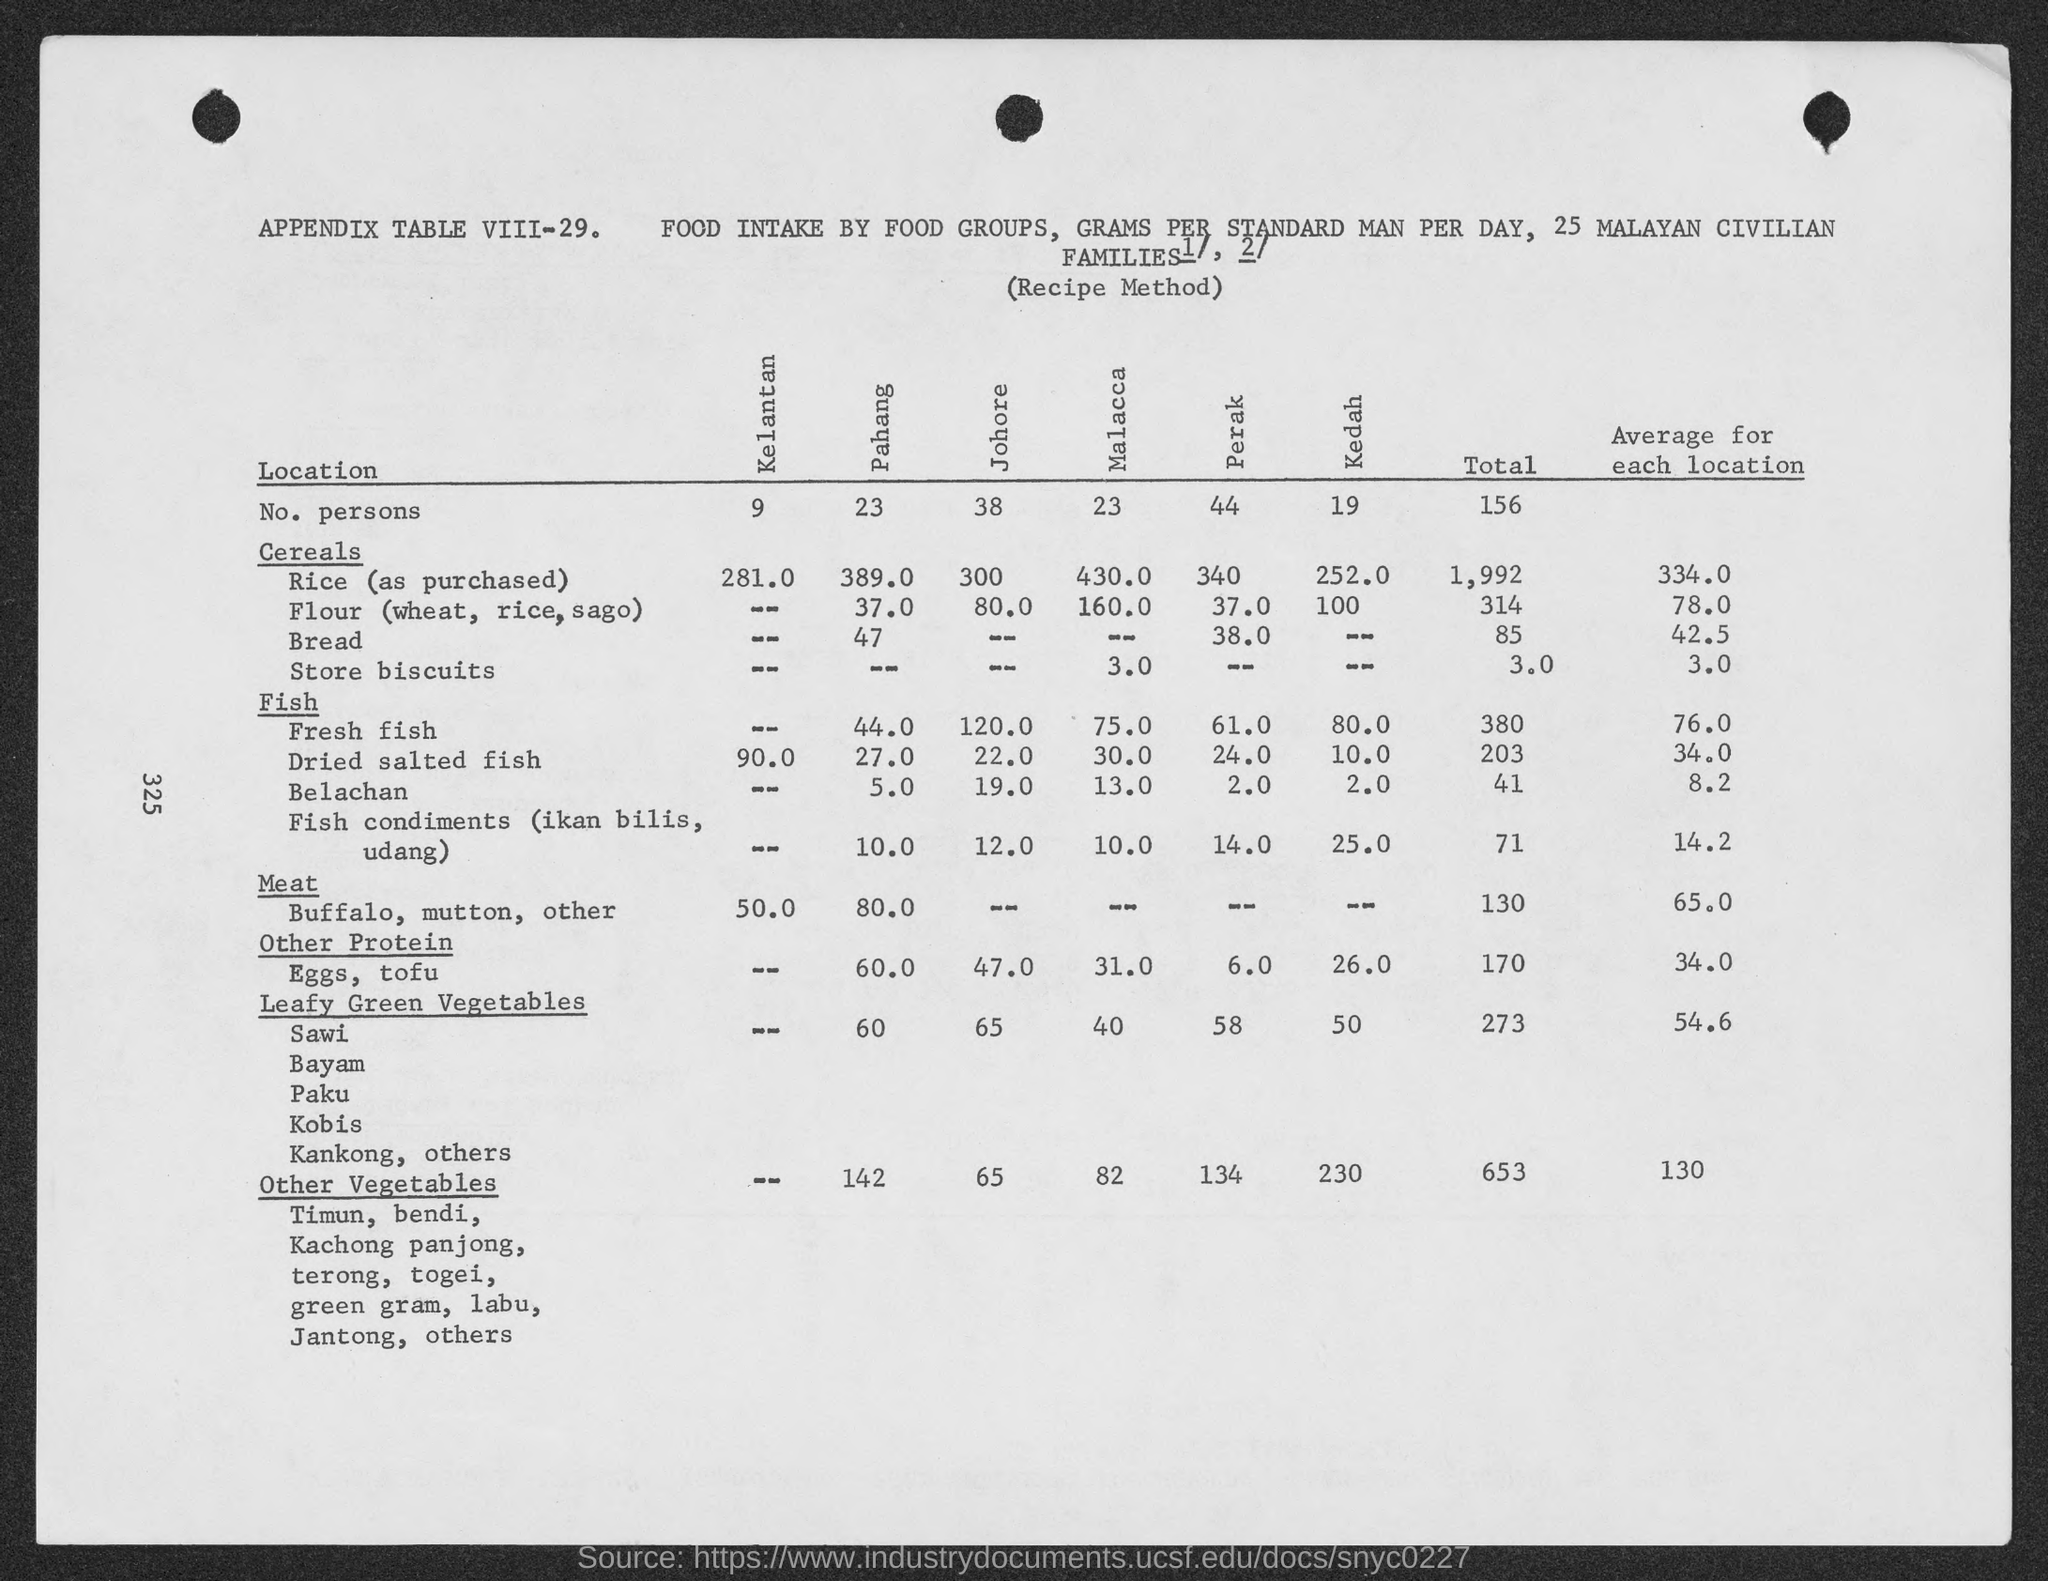WHAT IS THE TOTAL VALUE OF LEAFY GREEN VEGETABLES?
Ensure brevity in your answer.  273. What is the average for each location under the heading "other vegetables"?
Your answer should be very brief. 130. 